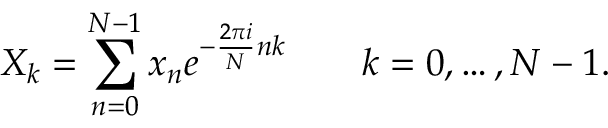<formula> <loc_0><loc_0><loc_500><loc_500>X _ { k } = \sum _ { n = 0 } ^ { N - 1 } x _ { n } e ^ { - { \frac { 2 \pi i } { N } } n k } \quad k = 0 , \dots , N - 1 .</formula> 